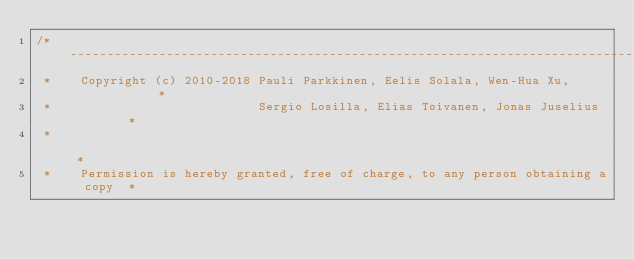<code> <loc_0><loc_0><loc_500><loc_500><_Cuda_>/*----------------------------------------------------------------------------------*
 *    Copyright (c) 2010-2018 Pauli Parkkinen, Eelis Solala, Wen-Hua Xu,            *
 *                            Sergio Losilla, Elias Toivanen, Jonas Juselius        *
 *                                                                                  *
 *    Permission is hereby granted, free of charge, to any person obtaining a copy  *</code> 